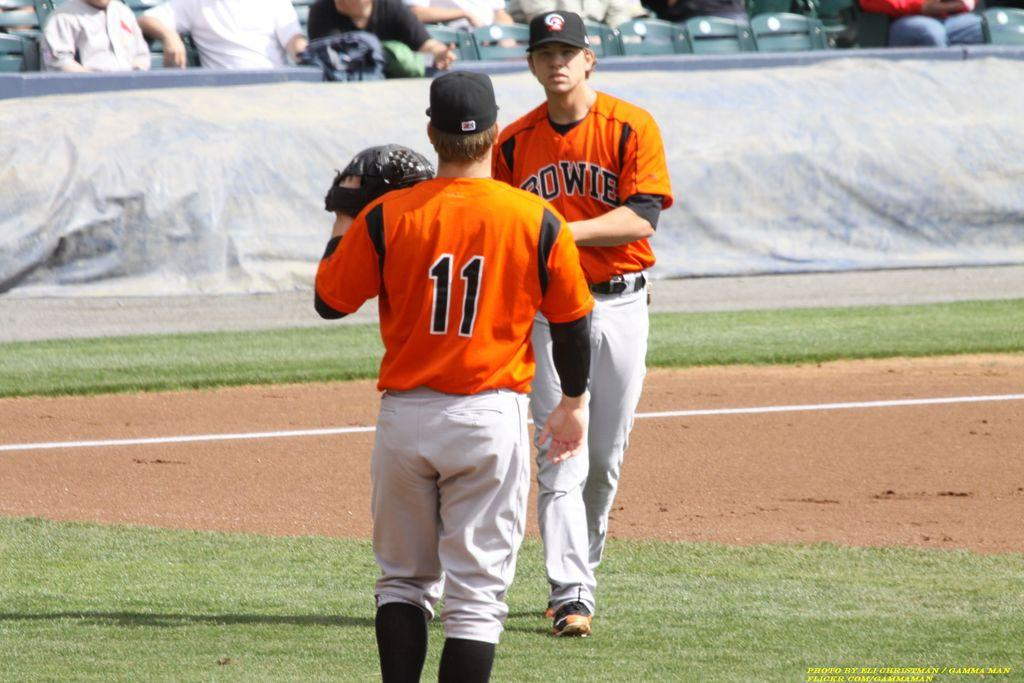<image>
Provide a brief description of the given image. Bowie is being represented by one of the baseball players. 